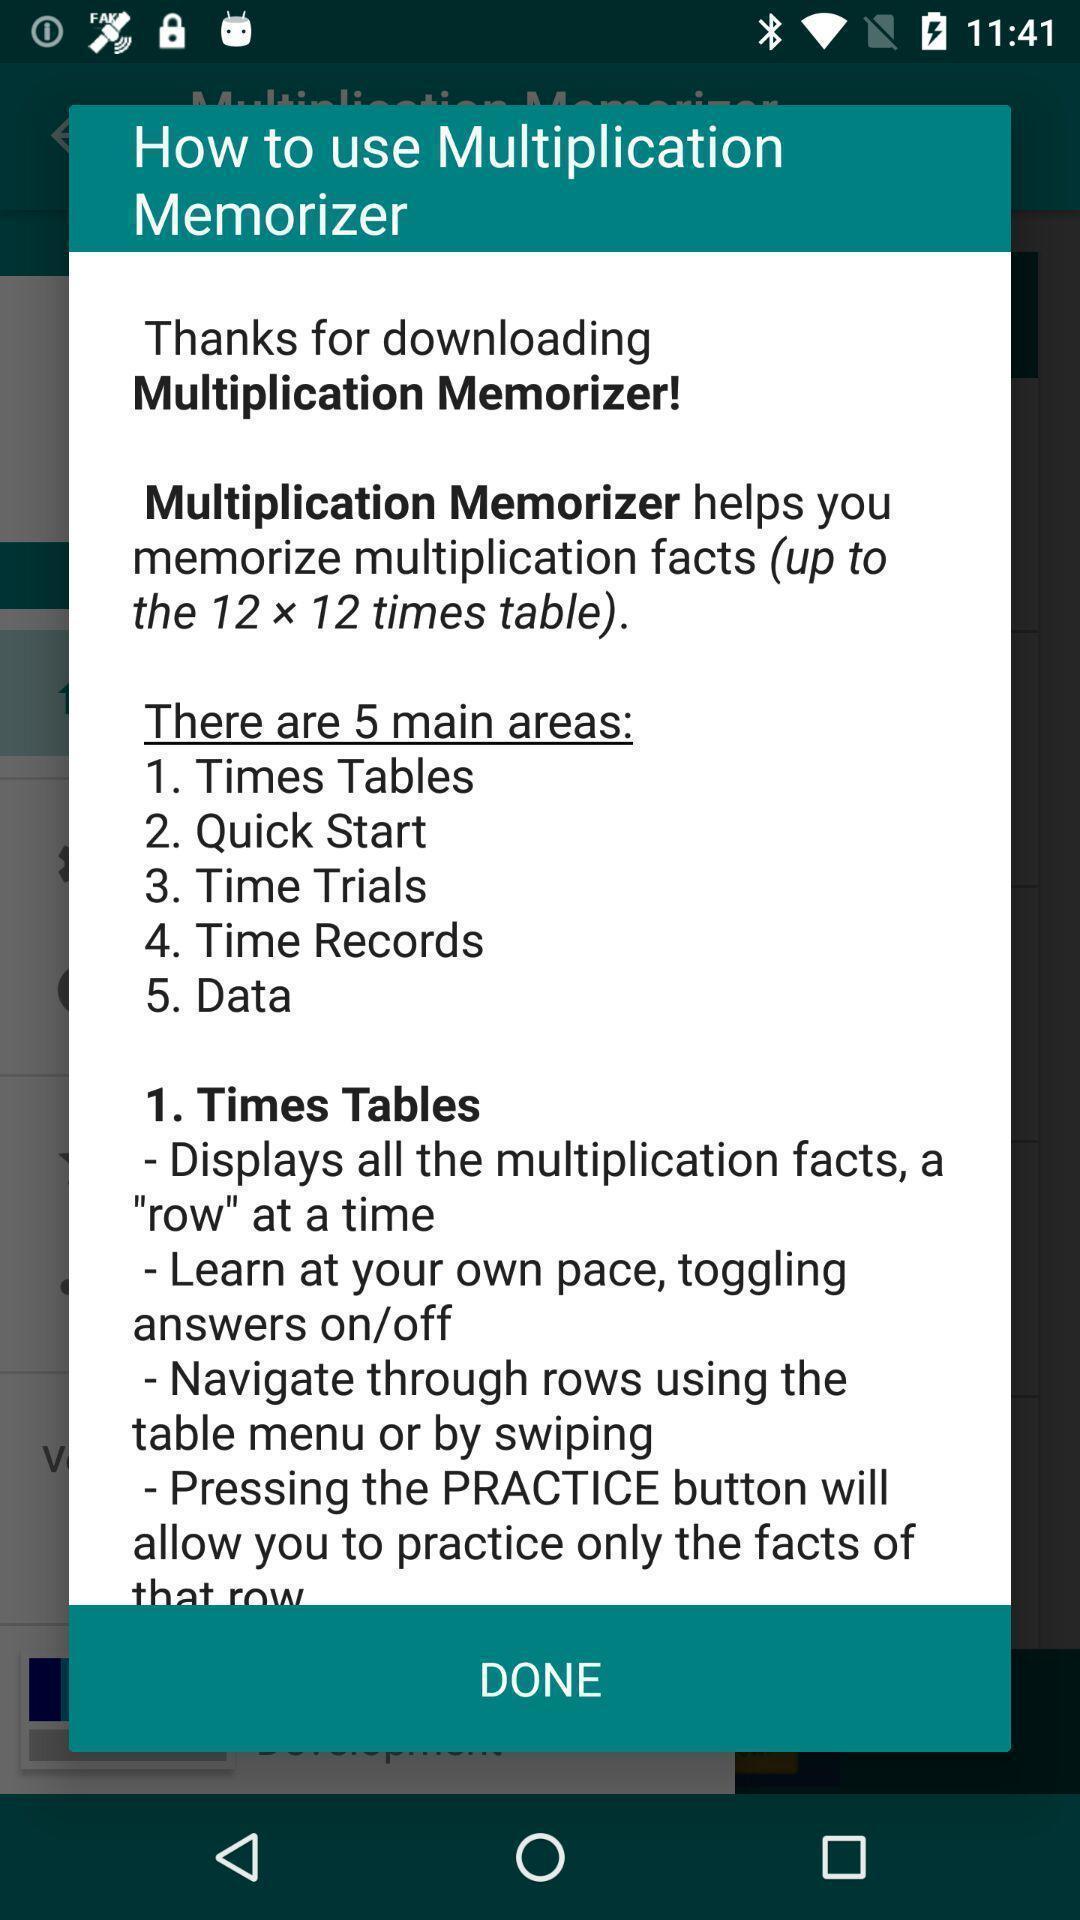Please provide a description for this image. Pop-up asking to select the option. 